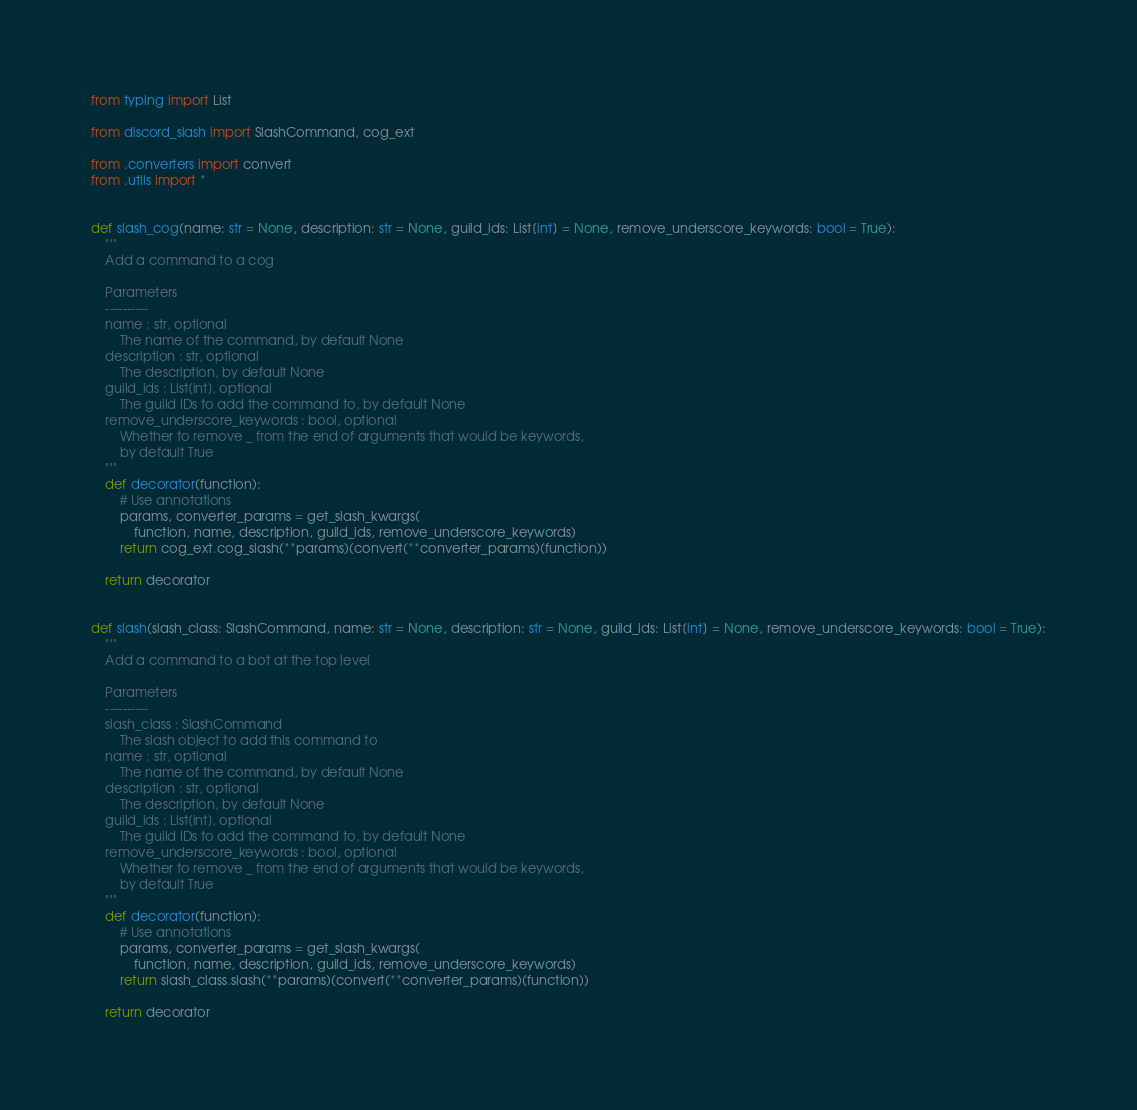Convert code to text. <code><loc_0><loc_0><loc_500><loc_500><_Python_>
from typing import List

from discord_slash import SlashCommand, cog_ext

from .converters import convert
from .utils import *


def slash_cog(name: str = None, description: str = None, guild_ids: List[int] = None, remove_underscore_keywords: bool = True):
    """
    Add a command to a cog

    Parameters
    ----------
    name : str, optional
        The name of the command, by default None
    description : str, optional
        The description, by default None
    guild_ids : List[int], optional
        The guild IDs to add the command to, by default None
    remove_underscore_keywords : bool, optional
        Whether to remove _ from the end of arguments that would be keywords,
        by default True
    """
    def decorator(function):
        # Use annotations
        params, converter_params = get_slash_kwargs(
            function, name, description, guild_ids, remove_underscore_keywords)
        return cog_ext.cog_slash(**params)(convert(**converter_params)(function))

    return decorator


def slash(slash_class: SlashCommand, name: str = None, description: str = None, guild_ids: List[int] = None, remove_underscore_keywords: bool = True):
    """
    Add a command to a bot at the top level

    Parameters
    ----------
    slash_class : SlashCommand
        The slash object to add this command to
    name : str, optional
        The name of the command, by default None
    description : str, optional
        The description, by default None
    guild_ids : List[int], optional
        The guild IDs to add the command to, by default None
    remove_underscore_keywords : bool, optional
        Whether to remove _ from the end of arguments that would be keywords,
        by default True
    """
    def decorator(function):
        # Use annotations
        params, converter_params = get_slash_kwargs(
            function, name, description, guild_ids, remove_underscore_keywords)
        return slash_class.slash(**params)(convert(**converter_params)(function))

    return decorator
</code> 